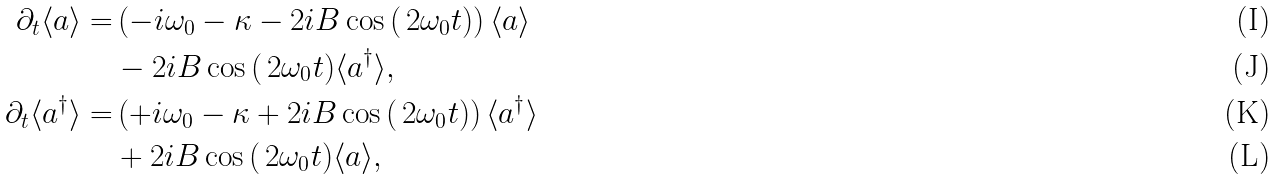Convert formula to latex. <formula><loc_0><loc_0><loc_500><loc_500>\partial _ { t } \langle a \rangle = & \left ( - i \omega _ { 0 } - \kappa - 2 i B \cos \, ( \, 2 \omega _ { 0 } t ) \right ) \langle a \rangle \\ & - 2 i B \cos \, ( \, 2 \omega _ { 0 } t ) \langle a ^ { \dagger } \rangle , \\ \partial _ { t } \langle a ^ { \dagger } \rangle = & \left ( + i \omega _ { 0 } - \kappa + 2 i B \cos \, ( \, 2 \omega _ { 0 } t ) \right ) \langle a ^ { \dagger } \rangle \\ & + 2 i B \cos \, ( \, 2 \omega _ { 0 } t ) \langle a \rangle ,</formula> 